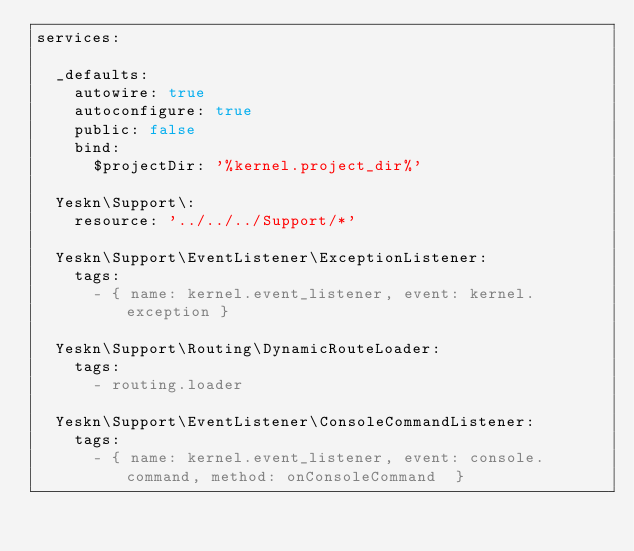<code> <loc_0><loc_0><loc_500><loc_500><_YAML_>services:

  _defaults:
    autowire: true
    autoconfigure: true
    public: false
    bind:
      $projectDir: '%kernel.project_dir%'

  Yeskn\Support\:
    resource: '../../../Support/*'

  Yeskn\Support\EventListener\ExceptionListener:
    tags:
      - { name: kernel.event_listener, event: kernel.exception }

  Yeskn\Support\Routing\DynamicRouteLoader:
    tags:
      - routing.loader

  Yeskn\Support\EventListener\ConsoleCommandListener:
    tags:
      - { name: kernel.event_listener, event: console.command, method: onConsoleCommand  }
</code> 